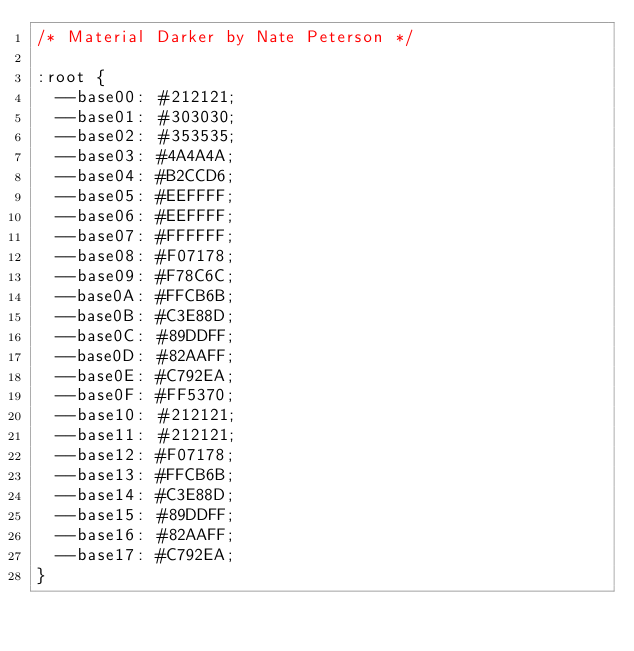<code> <loc_0><loc_0><loc_500><loc_500><_CSS_>/* Material Darker by Nate Peterson */

:root {
	--base00: #212121;
	--base01: #303030;
	--base02: #353535;
	--base03: #4A4A4A;
	--base04: #B2CCD6;
	--base05: #EEFFFF;
	--base06: #EEFFFF;
	--base07: #FFFFFF;
	--base08: #F07178;
	--base09: #F78C6C;
	--base0A: #FFCB6B;
	--base0B: #C3E88D;
	--base0C: #89DDFF;
	--base0D: #82AAFF;
	--base0E: #C792EA;
	--base0F: #FF5370;
	--base10: #212121;
	--base11: #212121;
	--base12: #F07178;
	--base13: #FFCB6B;
	--base14: #C3E88D;
	--base15: #89DDFF;
	--base16: #82AAFF;
	--base17: #C792EA;
}
</code> 